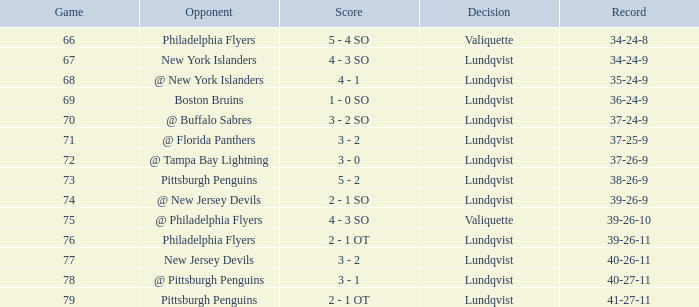Which score's game was less than 69 when the march was bigger than 2 and the opponents were the New York Islanders? 4 - 3 SO. 